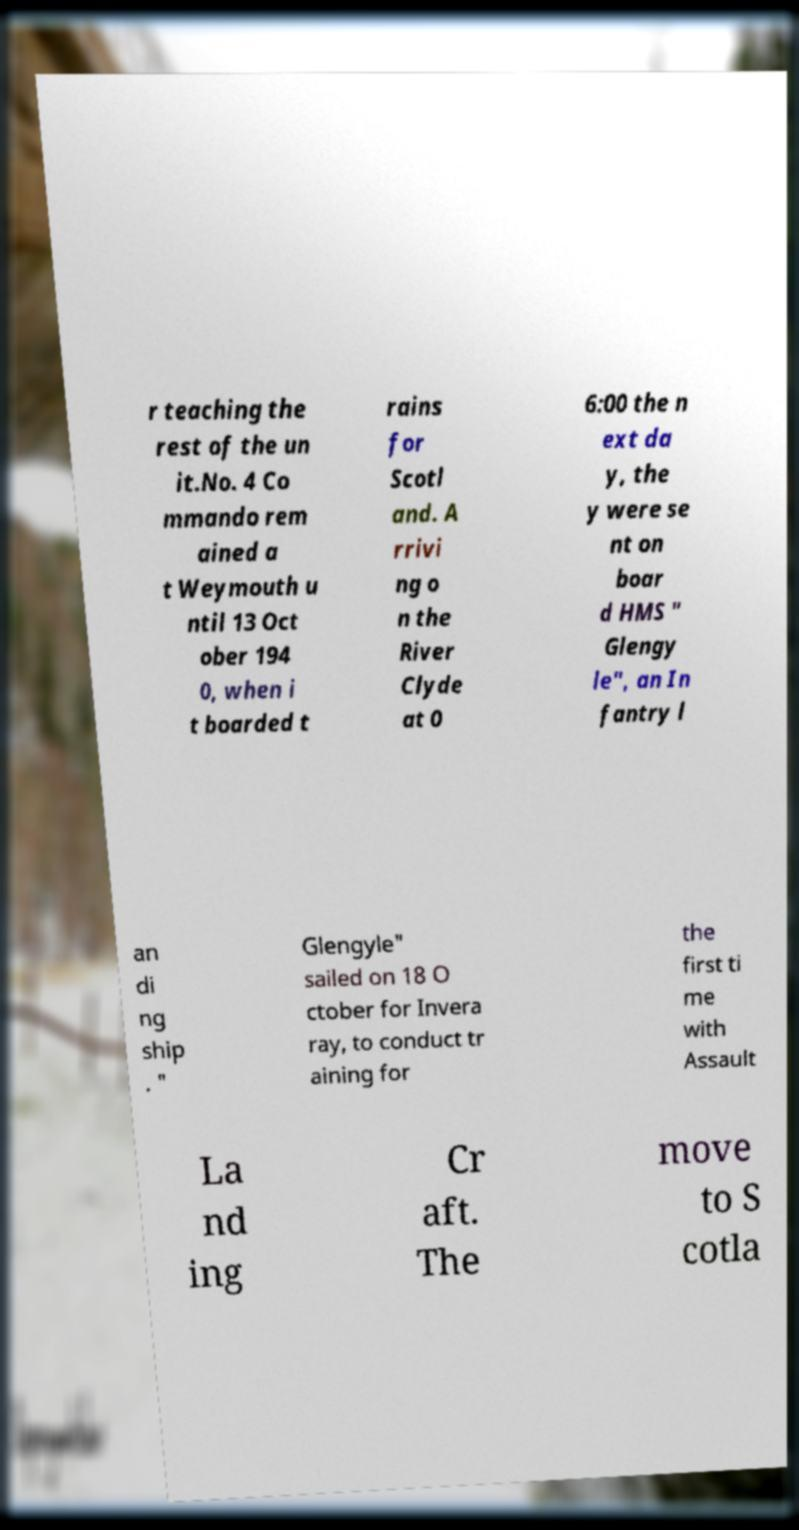Please identify and transcribe the text found in this image. r teaching the rest of the un it.No. 4 Co mmando rem ained a t Weymouth u ntil 13 Oct ober 194 0, when i t boarded t rains for Scotl and. A rrivi ng o n the River Clyde at 0 6:00 the n ext da y, the y were se nt on boar d HMS " Glengy le", an In fantry l an di ng ship . " Glengyle" sailed on 18 O ctober for Invera ray, to conduct tr aining for the first ti me with Assault La nd ing Cr aft. The move to S cotla 